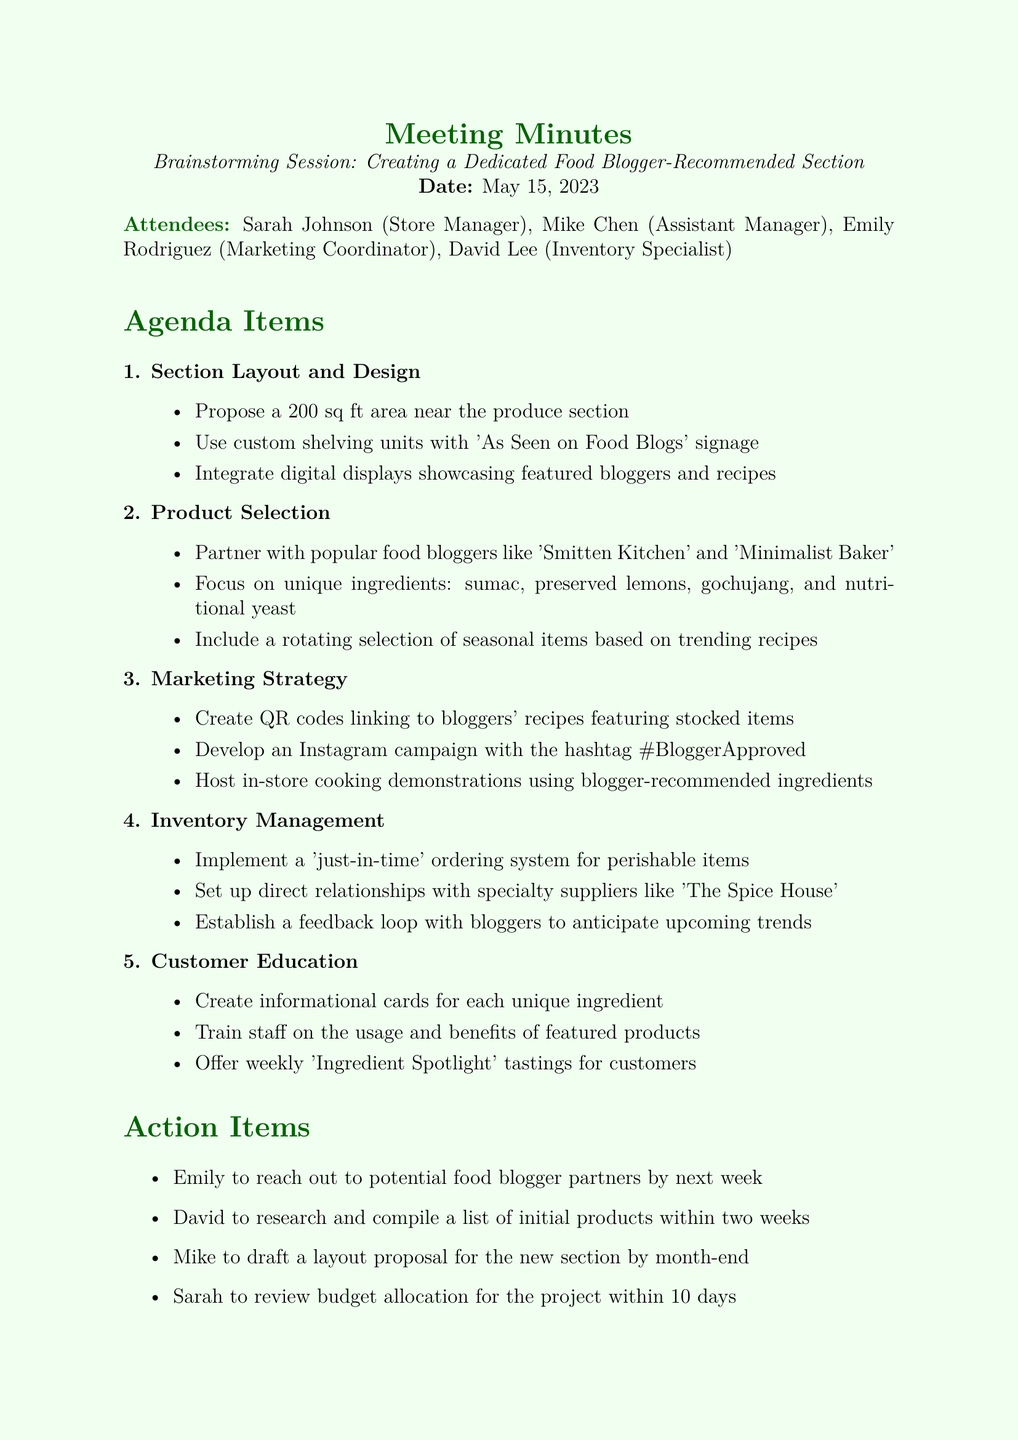What is the date of the meeting? The date of the meeting is explicitly mentioned in the document as May 15, 2023.
Answer: May 15, 2023 Who is the Marketing Coordinator? The document lists attendees and their roles, identifying Emily Rodriguez as the Marketing Coordinator.
Answer: Emily Rodriguez What is the proposed area size for the new section? The agenda item regarding section layout and design specifies a proposed area of 200 sq ft.
Answer: 200 sq ft Which food bloggers are mentioned for partnership? The document indicates specific popular food bloggers to partner with, namely 'Smitten Kitchen' and 'Minimalist Baker'.
Answer: Smitten Kitchen and Minimalist Baker What QR code strategy is mentioned? One of the marketing strategies involves creating QR codes linking to bloggers' recipes, as outlined in the agenda.
Answer: Linking to bloggers' recipes How long does Emily have to reach out to potential food blogger partners? The action items state that Emily is to reach out by next week, indicating a short timeframe for this task.
Answer: By next week What type of ordering system is suggested for inventory management? The inventory management section specifies the implementation of a 'just-in-time' ordering system for perishable items.
Answer: Just-in-time What is one way to educate customers on unique ingredients? The customer education agenda item mentions creating informational cards for each unique ingredient as a method to educate customers.
Answer: Informational cards 